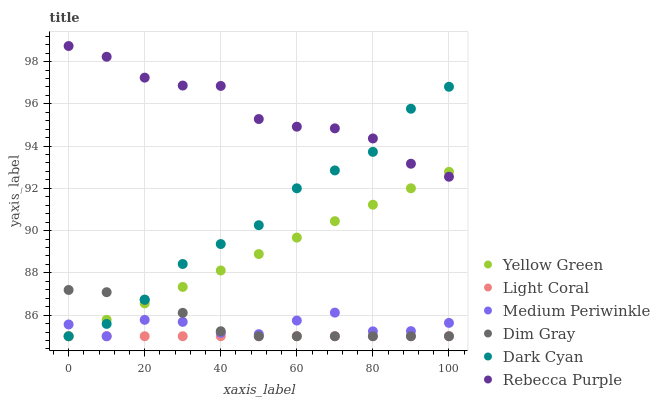Does Light Coral have the minimum area under the curve?
Answer yes or no. Yes. Does Rebecca Purple have the maximum area under the curve?
Answer yes or no. Yes. Does Yellow Green have the minimum area under the curve?
Answer yes or no. No. Does Yellow Green have the maximum area under the curve?
Answer yes or no. No. Is Yellow Green the smoothest?
Answer yes or no. Yes. Is Medium Periwinkle the roughest?
Answer yes or no. Yes. Is Medium Periwinkle the smoothest?
Answer yes or no. No. Is Yellow Green the roughest?
Answer yes or no. No. Does Dim Gray have the lowest value?
Answer yes or no. Yes. Does Rebecca Purple have the lowest value?
Answer yes or no. No. Does Rebecca Purple have the highest value?
Answer yes or no. Yes. Does Yellow Green have the highest value?
Answer yes or no. No. Is Medium Periwinkle less than Rebecca Purple?
Answer yes or no. Yes. Is Rebecca Purple greater than Dim Gray?
Answer yes or no. Yes. Does Dim Gray intersect Light Coral?
Answer yes or no. Yes. Is Dim Gray less than Light Coral?
Answer yes or no. No. Is Dim Gray greater than Light Coral?
Answer yes or no. No. Does Medium Periwinkle intersect Rebecca Purple?
Answer yes or no. No. 